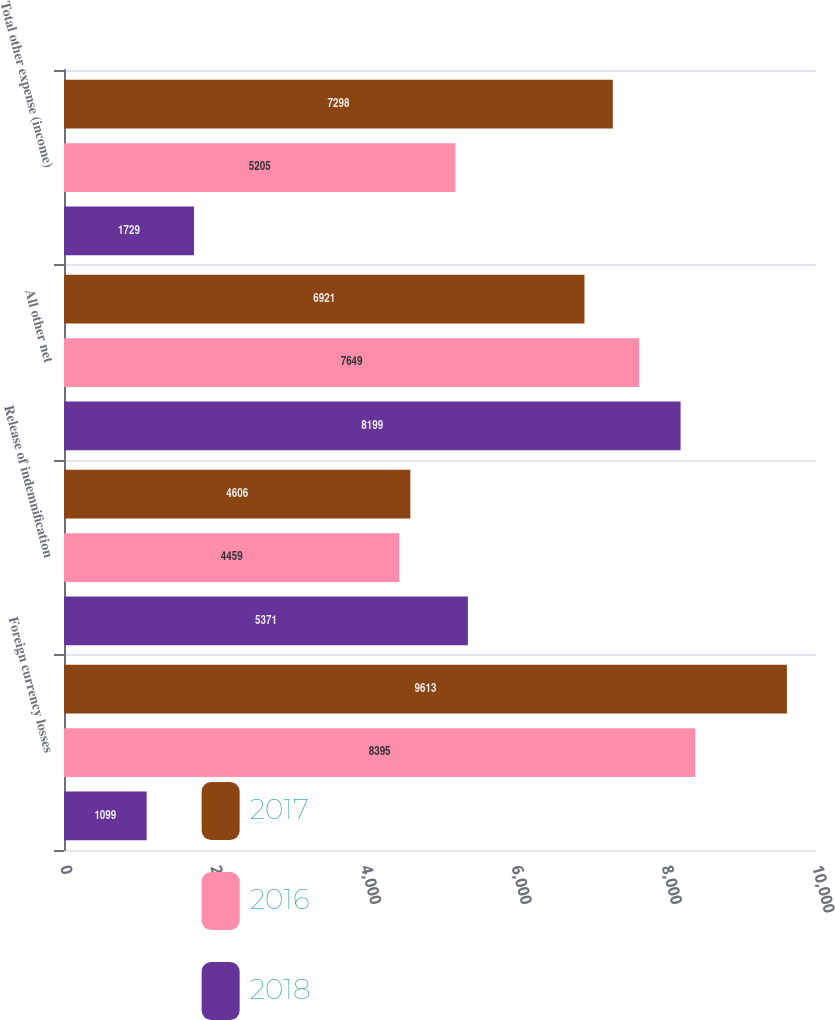<chart> <loc_0><loc_0><loc_500><loc_500><stacked_bar_chart><ecel><fcel>Foreign currency losses<fcel>Release of indemnification<fcel>All other net<fcel>Total other expense (income)<nl><fcel>2017<fcel>9613<fcel>4606<fcel>6921<fcel>7298<nl><fcel>2016<fcel>8395<fcel>4459<fcel>7649<fcel>5205<nl><fcel>2018<fcel>1099<fcel>5371<fcel>8199<fcel>1729<nl></chart> 